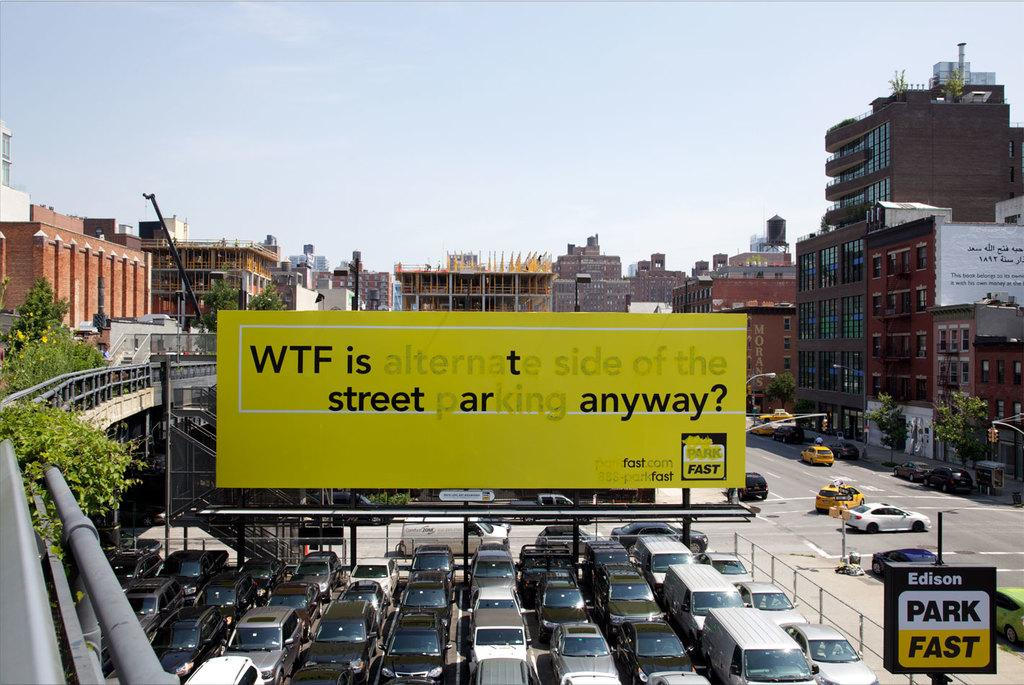<image>
Render a clear and concise summary of the photo. A large billboard over a parking lot that says "WTF is alternate side of the street parking anyway?" 